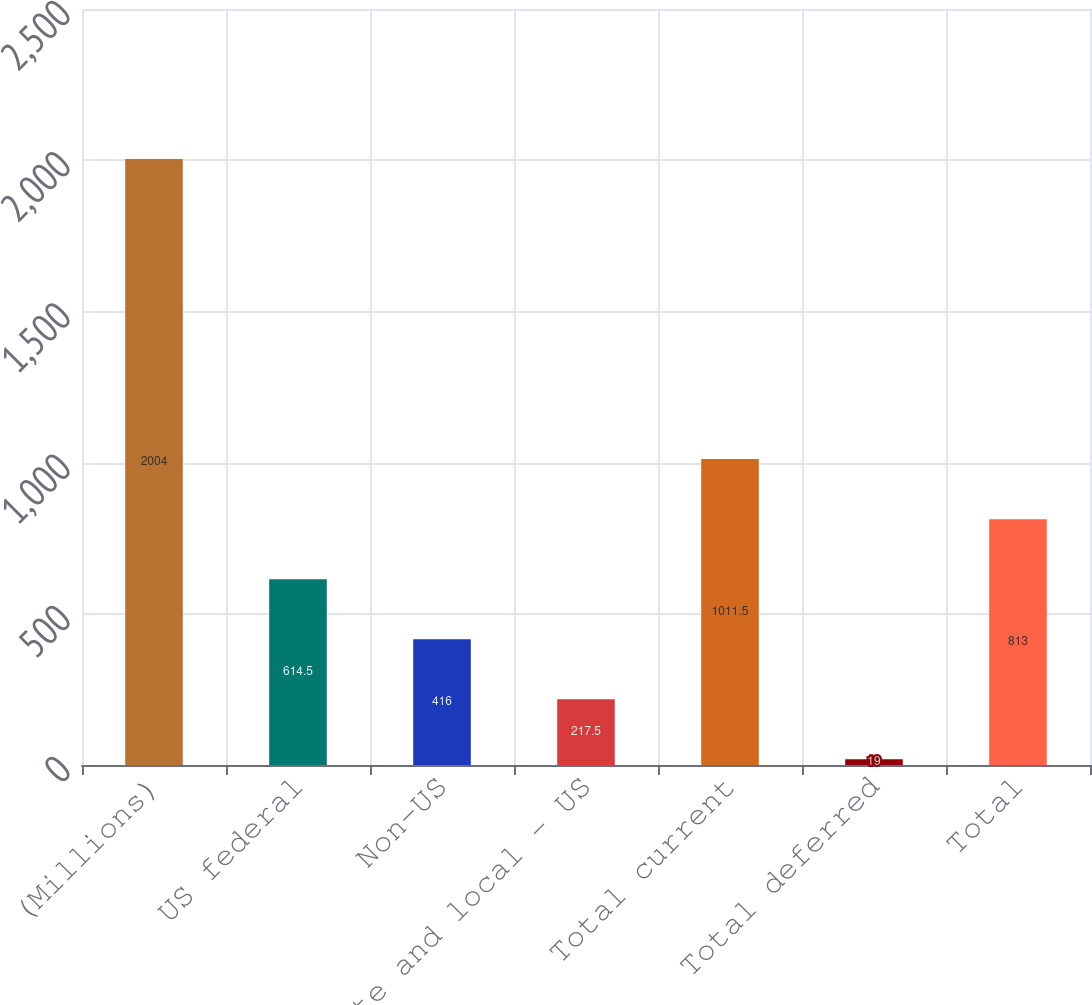Convert chart to OTSL. <chart><loc_0><loc_0><loc_500><loc_500><bar_chart><fcel>(Millions)<fcel>US federal<fcel>Non-US<fcel>State and local - US<fcel>Total current<fcel>Total deferred<fcel>Total<nl><fcel>2004<fcel>614.5<fcel>416<fcel>217.5<fcel>1011.5<fcel>19<fcel>813<nl></chart> 